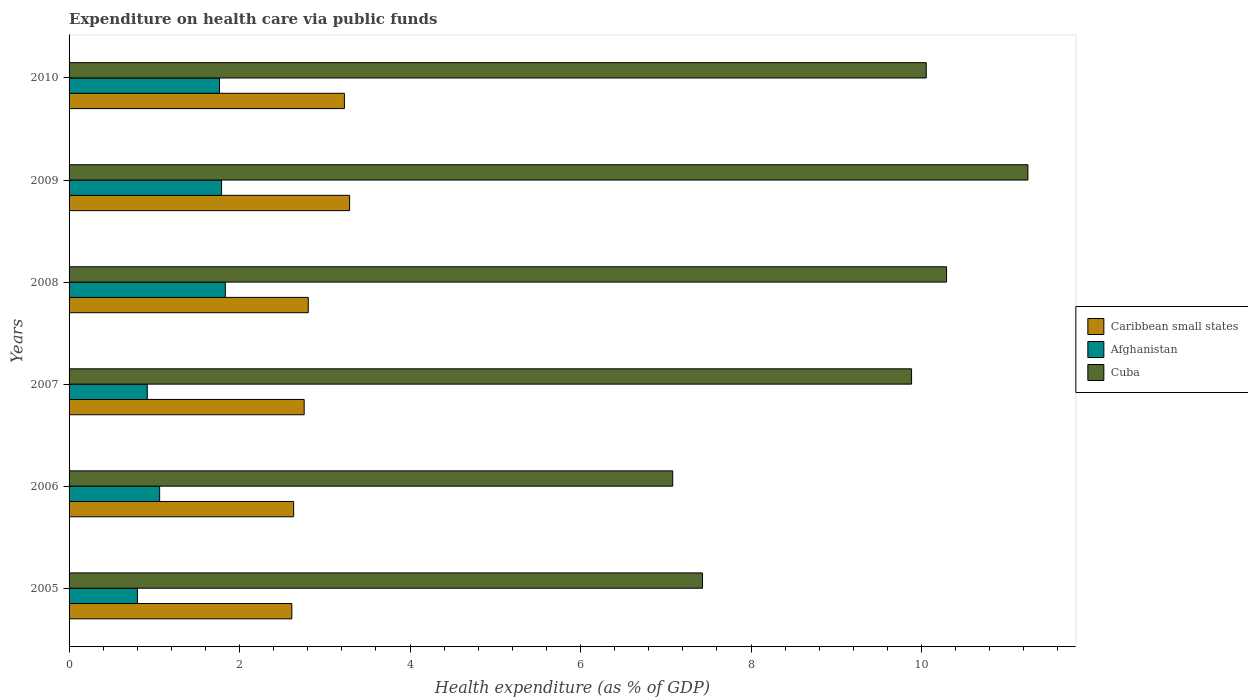Are the number of bars per tick equal to the number of legend labels?
Offer a terse response. Yes. How many bars are there on the 5th tick from the bottom?
Give a very brief answer. 3. What is the label of the 5th group of bars from the top?
Give a very brief answer. 2006. What is the expenditure made on health care in Afghanistan in 2010?
Offer a terse response. 1.76. Across all years, what is the maximum expenditure made on health care in Afghanistan?
Provide a short and direct response. 1.83. Across all years, what is the minimum expenditure made on health care in Cuba?
Provide a succinct answer. 7.08. In which year was the expenditure made on health care in Cuba maximum?
Your answer should be compact. 2009. In which year was the expenditure made on health care in Cuba minimum?
Your answer should be compact. 2006. What is the total expenditure made on health care in Caribbean small states in the graph?
Your response must be concise. 17.33. What is the difference between the expenditure made on health care in Cuba in 2005 and that in 2007?
Your answer should be very brief. -2.45. What is the difference between the expenditure made on health care in Caribbean small states in 2006 and the expenditure made on health care in Cuba in 2007?
Give a very brief answer. -7.25. What is the average expenditure made on health care in Afghanistan per year?
Your answer should be compact. 1.36. In the year 2006, what is the difference between the expenditure made on health care in Afghanistan and expenditure made on health care in Caribbean small states?
Provide a succinct answer. -1.57. In how many years, is the expenditure made on health care in Caribbean small states greater than 0.8 %?
Offer a very short reply. 6. What is the ratio of the expenditure made on health care in Cuba in 2005 to that in 2007?
Provide a succinct answer. 0.75. Is the difference between the expenditure made on health care in Afghanistan in 2007 and 2010 greater than the difference between the expenditure made on health care in Caribbean small states in 2007 and 2010?
Give a very brief answer. No. What is the difference between the highest and the second highest expenditure made on health care in Caribbean small states?
Ensure brevity in your answer.  0.06. What is the difference between the highest and the lowest expenditure made on health care in Afghanistan?
Offer a very short reply. 1.03. In how many years, is the expenditure made on health care in Caribbean small states greater than the average expenditure made on health care in Caribbean small states taken over all years?
Make the answer very short. 2. Is the sum of the expenditure made on health care in Cuba in 2007 and 2009 greater than the maximum expenditure made on health care in Afghanistan across all years?
Your response must be concise. Yes. What does the 3rd bar from the top in 2005 represents?
Your answer should be very brief. Caribbean small states. What does the 1st bar from the bottom in 2005 represents?
Keep it short and to the point. Caribbean small states. How many bars are there?
Your answer should be very brief. 18. How many years are there in the graph?
Provide a short and direct response. 6. Are the values on the major ticks of X-axis written in scientific E-notation?
Your answer should be compact. No. Does the graph contain any zero values?
Your response must be concise. No. Where does the legend appear in the graph?
Give a very brief answer. Center right. How are the legend labels stacked?
Your answer should be compact. Vertical. What is the title of the graph?
Make the answer very short. Expenditure on health care via public funds. What is the label or title of the X-axis?
Make the answer very short. Health expenditure (as % of GDP). What is the label or title of the Y-axis?
Your answer should be very brief. Years. What is the Health expenditure (as % of GDP) in Caribbean small states in 2005?
Make the answer very short. 2.61. What is the Health expenditure (as % of GDP) in Afghanistan in 2005?
Your response must be concise. 0.8. What is the Health expenditure (as % of GDP) in Cuba in 2005?
Make the answer very short. 7.43. What is the Health expenditure (as % of GDP) in Caribbean small states in 2006?
Your response must be concise. 2.63. What is the Health expenditure (as % of GDP) in Afghanistan in 2006?
Offer a very short reply. 1.06. What is the Health expenditure (as % of GDP) of Cuba in 2006?
Provide a short and direct response. 7.08. What is the Health expenditure (as % of GDP) in Caribbean small states in 2007?
Give a very brief answer. 2.76. What is the Health expenditure (as % of GDP) of Afghanistan in 2007?
Give a very brief answer. 0.92. What is the Health expenditure (as % of GDP) in Cuba in 2007?
Provide a succinct answer. 9.88. What is the Health expenditure (as % of GDP) in Caribbean small states in 2008?
Provide a succinct answer. 2.81. What is the Health expenditure (as % of GDP) in Afghanistan in 2008?
Your answer should be very brief. 1.83. What is the Health expenditure (as % of GDP) in Cuba in 2008?
Provide a succinct answer. 10.29. What is the Health expenditure (as % of GDP) in Caribbean small states in 2009?
Provide a succinct answer. 3.29. What is the Health expenditure (as % of GDP) of Afghanistan in 2009?
Provide a short and direct response. 1.79. What is the Health expenditure (as % of GDP) of Cuba in 2009?
Offer a very short reply. 11.25. What is the Health expenditure (as % of GDP) of Caribbean small states in 2010?
Your answer should be very brief. 3.23. What is the Health expenditure (as % of GDP) in Afghanistan in 2010?
Provide a succinct answer. 1.76. What is the Health expenditure (as % of GDP) in Cuba in 2010?
Give a very brief answer. 10.06. Across all years, what is the maximum Health expenditure (as % of GDP) of Caribbean small states?
Ensure brevity in your answer.  3.29. Across all years, what is the maximum Health expenditure (as % of GDP) in Afghanistan?
Offer a very short reply. 1.83. Across all years, what is the maximum Health expenditure (as % of GDP) in Cuba?
Keep it short and to the point. 11.25. Across all years, what is the minimum Health expenditure (as % of GDP) in Caribbean small states?
Make the answer very short. 2.61. Across all years, what is the minimum Health expenditure (as % of GDP) of Afghanistan?
Provide a succinct answer. 0.8. Across all years, what is the minimum Health expenditure (as % of GDP) of Cuba?
Your answer should be compact. 7.08. What is the total Health expenditure (as % of GDP) of Caribbean small states in the graph?
Your response must be concise. 17.33. What is the total Health expenditure (as % of GDP) of Afghanistan in the graph?
Offer a terse response. 8.17. What is the total Health expenditure (as % of GDP) of Cuba in the graph?
Your answer should be compact. 55.99. What is the difference between the Health expenditure (as % of GDP) in Caribbean small states in 2005 and that in 2006?
Your response must be concise. -0.02. What is the difference between the Health expenditure (as % of GDP) of Afghanistan in 2005 and that in 2006?
Keep it short and to the point. -0.26. What is the difference between the Health expenditure (as % of GDP) in Cuba in 2005 and that in 2006?
Provide a short and direct response. 0.35. What is the difference between the Health expenditure (as % of GDP) of Caribbean small states in 2005 and that in 2007?
Offer a terse response. -0.14. What is the difference between the Health expenditure (as % of GDP) of Afghanistan in 2005 and that in 2007?
Your answer should be compact. -0.12. What is the difference between the Health expenditure (as % of GDP) of Cuba in 2005 and that in 2007?
Provide a short and direct response. -2.45. What is the difference between the Health expenditure (as % of GDP) in Caribbean small states in 2005 and that in 2008?
Give a very brief answer. -0.19. What is the difference between the Health expenditure (as % of GDP) in Afghanistan in 2005 and that in 2008?
Provide a short and direct response. -1.03. What is the difference between the Health expenditure (as % of GDP) of Cuba in 2005 and that in 2008?
Keep it short and to the point. -2.86. What is the difference between the Health expenditure (as % of GDP) of Caribbean small states in 2005 and that in 2009?
Give a very brief answer. -0.68. What is the difference between the Health expenditure (as % of GDP) in Afghanistan in 2005 and that in 2009?
Your answer should be very brief. -0.99. What is the difference between the Health expenditure (as % of GDP) of Cuba in 2005 and that in 2009?
Your answer should be compact. -3.82. What is the difference between the Health expenditure (as % of GDP) of Caribbean small states in 2005 and that in 2010?
Keep it short and to the point. -0.62. What is the difference between the Health expenditure (as % of GDP) in Afghanistan in 2005 and that in 2010?
Provide a succinct answer. -0.96. What is the difference between the Health expenditure (as % of GDP) of Cuba in 2005 and that in 2010?
Your response must be concise. -2.62. What is the difference between the Health expenditure (as % of GDP) of Caribbean small states in 2006 and that in 2007?
Your response must be concise. -0.12. What is the difference between the Health expenditure (as % of GDP) in Afghanistan in 2006 and that in 2007?
Make the answer very short. 0.14. What is the difference between the Health expenditure (as % of GDP) of Cuba in 2006 and that in 2007?
Your response must be concise. -2.8. What is the difference between the Health expenditure (as % of GDP) of Caribbean small states in 2006 and that in 2008?
Your answer should be very brief. -0.17. What is the difference between the Health expenditure (as % of GDP) of Afghanistan in 2006 and that in 2008?
Make the answer very short. -0.77. What is the difference between the Health expenditure (as % of GDP) of Cuba in 2006 and that in 2008?
Keep it short and to the point. -3.21. What is the difference between the Health expenditure (as % of GDP) of Caribbean small states in 2006 and that in 2009?
Your answer should be very brief. -0.66. What is the difference between the Health expenditure (as % of GDP) of Afghanistan in 2006 and that in 2009?
Your answer should be compact. -0.73. What is the difference between the Health expenditure (as % of GDP) in Cuba in 2006 and that in 2009?
Offer a terse response. -4.17. What is the difference between the Health expenditure (as % of GDP) in Caribbean small states in 2006 and that in 2010?
Your answer should be compact. -0.6. What is the difference between the Health expenditure (as % of GDP) of Afghanistan in 2006 and that in 2010?
Give a very brief answer. -0.7. What is the difference between the Health expenditure (as % of GDP) of Cuba in 2006 and that in 2010?
Make the answer very short. -2.97. What is the difference between the Health expenditure (as % of GDP) of Caribbean small states in 2007 and that in 2008?
Make the answer very short. -0.05. What is the difference between the Health expenditure (as % of GDP) in Afghanistan in 2007 and that in 2008?
Provide a succinct answer. -0.92. What is the difference between the Health expenditure (as % of GDP) of Cuba in 2007 and that in 2008?
Provide a succinct answer. -0.41. What is the difference between the Health expenditure (as % of GDP) in Caribbean small states in 2007 and that in 2009?
Make the answer very short. -0.53. What is the difference between the Health expenditure (as % of GDP) of Afghanistan in 2007 and that in 2009?
Make the answer very short. -0.87. What is the difference between the Health expenditure (as % of GDP) of Cuba in 2007 and that in 2009?
Your response must be concise. -1.36. What is the difference between the Health expenditure (as % of GDP) in Caribbean small states in 2007 and that in 2010?
Keep it short and to the point. -0.47. What is the difference between the Health expenditure (as % of GDP) of Afghanistan in 2007 and that in 2010?
Offer a very short reply. -0.85. What is the difference between the Health expenditure (as % of GDP) of Cuba in 2007 and that in 2010?
Ensure brevity in your answer.  -0.17. What is the difference between the Health expenditure (as % of GDP) in Caribbean small states in 2008 and that in 2009?
Give a very brief answer. -0.48. What is the difference between the Health expenditure (as % of GDP) of Afghanistan in 2008 and that in 2009?
Make the answer very short. 0.04. What is the difference between the Health expenditure (as % of GDP) in Cuba in 2008 and that in 2009?
Provide a succinct answer. -0.95. What is the difference between the Health expenditure (as % of GDP) in Caribbean small states in 2008 and that in 2010?
Provide a succinct answer. -0.42. What is the difference between the Health expenditure (as % of GDP) in Afghanistan in 2008 and that in 2010?
Provide a succinct answer. 0.07. What is the difference between the Health expenditure (as % of GDP) of Cuba in 2008 and that in 2010?
Ensure brevity in your answer.  0.24. What is the difference between the Health expenditure (as % of GDP) in Caribbean small states in 2009 and that in 2010?
Offer a very short reply. 0.06. What is the difference between the Health expenditure (as % of GDP) in Afghanistan in 2009 and that in 2010?
Your answer should be very brief. 0.02. What is the difference between the Health expenditure (as % of GDP) of Cuba in 2009 and that in 2010?
Make the answer very short. 1.19. What is the difference between the Health expenditure (as % of GDP) in Caribbean small states in 2005 and the Health expenditure (as % of GDP) in Afghanistan in 2006?
Provide a succinct answer. 1.55. What is the difference between the Health expenditure (as % of GDP) in Caribbean small states in 2005 and the Health expenditure (as % of GDP) in Cuba in 2006?
Your response must be concise. -4.47. What is the difference between the Health expenditure (as % of GDP) of Afghanistan in 2005 and the Health expenditure (as % of GDP) of Cuba in 2006?
Give a very brief answer. -6.28. What is the difference between the Health expenditure (as % of GDP) of Caribbean small states in 2005 and the Health expenditure (as % of GDP) of Afghanistan in 2007?
Offer a terse response. 1.7. What is the difference between the Health expenditure (as % of GDP) in Caribbean small states in 2005 and the Health expenditure (as % of GDP) in Cuba in 2007?
Provide a succinct answer. -7.27. What is the difference between the Health expenditure (as % of GDP) of Afghanistan in 2005 and the Health expenditure (as % of GDP) of Cuba in 2007?
Make the answer very short. -9.08. What is the difference between the Health expenditure (as % of GDP) in Caribbean small states in 2005 and the Health expenditure (as % of GDP) in Afghanistan in 2008?
Your response must be concise. 0.78. What is the difference between the Health expenditure (as % of GDP) of Caribbean small states in 2005 and the Health expenditure (as % of GDP) of Cuba in 2008?
Your response must be concise. -7.68. What is the difference between the Health expenditure (as % of GDP) of Afghanistan in 2005 and the Health expenditure (as % of GDP) of Cuba in 2008?
Give a very brief answer. -9.49. What is the difference between the Health expenditure (as % of GDP) in Caribbean small states in 2005 and the Health expenditure (as % of GDP) in Afghanistan in 2009?
Your response must be concise. 0.82. What is the difference between the Health expenditure (as % of GDP) in Caribbean small states in 2005 and the Health expenditure (as % of GDP) in Cuba in 2009?
Your answer should be compact. -8.63. What is the difference between the Health expenditure (as % of GDP) in Afghanistan in 2005 and the Health expenditure (as % of GDP) in Cuba in 2009?
Ensure brevity in your answer.  -10.45. What is the difference between the Health expenditure (as % of GDP) in Caribbean small states in 2005 and the Health expenditure (as % of GDP) in Afghanistan in 2010?
Keep it short and to the point. 0.85. What is the difference between the Health expenditure (as % of GDP) of Caribbean small states in 2005 and the Health expenditure (as % of GDP) of Cuba in 2010?
Make the answer very short. -7.44. What is the difference between the Health expenditure (as % of GDP) in Afghanistan in 2005 and the Health expenditure (as % of GDP) in Cuba in 2010?
Provide a succinct answer. -9.25. What is the difference between the Health expenditure (as % of GDP) in Caribbean small states in 2006 and the Health expenditure (as % of GDP) in Afghanistan in 2007?
Give a very brief answer. 1.72. What is the difference between the Health expenditure (as % of GDP) of Caribbean small states in 2006 and the Health expenditure (as % of GDP) of Cuba in 2007?
Provide a succinct answer. -7.25. What is the difference between the Health expenditure (as % of GDP) in Afghanistan in 2006 and the Health expenditure (as % of GDP) in Cuba in 2007?
Your answer should be compact. -8.82. What is the difference between the Health expenditure (as % of GDP) of Caribbean small states in 2006 and the Health expenditure (as % of GDP) of Afghanistan in 2008?
Give a very brief answer. 0.8. What is the difference between the Health expenditure (as % of GDP) in Caribbean small states in 2006 and the Health expenditure (as % of GDP) in Cuba in 2008?
Make the answer very short. -7.66. What is the difference between the Health expenditure (as % of GDP) of Afghanistan in 2006 and the Health expenditure (as % of GDP) of Cuba in 2008?
Your response must be concise. -9.23. What is the difference between the Health expenditure (as % of GDP) of Caribbean small states in 2006 and the Health expenditure (as % of GDP) of Afghanistan in 2009?
Offer a very short reply. 0.85. What is the difference between the Health expenditure (as % of GDP) of Caribbean small states in 2006 and the Health expenditure (as % of GDP) of Cuba in 2009?
Keep it short and to the point. -8.61. What is the difference between the Health expenditure (as % of GDP) in Afghanistan in 2006 and the Health expenditure (as % of GDP) in Cuba in 2009?
Your answer should be compact. -10.19. What is the difference between the Health expenditure (as % of GDP) in Caribbean small states in 2006 and the Health expenditure (as % of GDP) in Afghanistan in 2010?
Your answer should be very brief. 0.87. What is the difference between the Health expenditure (as % of GDP) of Caribbean small states in 2006 and the Health expenditure (as % of GDP) of Cuba in 2010?
Keep it short and to the point. -7.42. What is the difference between the Health expenditure (as % of GDP) of Afghanistan in 2006 and the Health expenditure (as % of GDP) of Cuba in 2010?
Ensure brevity in your answer.  -8.99. What is the difference between the Health expenditure (as % of GDP) of Caribbean small states in 2007 and the Health expenditure (as % of GDP) of Afghanistan in 2008?
Your answer should be compact. 0.93. What is the difference between the Health expenditure (as % of GDP) of Caribbean small states in 2007 and the Health expenditure (as % of GDP) of Cuba in 2008?
Provide a short and direct response. -7.54. What is the difference between the Health expenditure (as % of GDP) in Afghanistan in 2007 and the Health expenditure (as % of GDP) in Cuba in 2008?
Your response must be concise. -9.38. What is the difference between the Health expenditure (as % of GDP) of Caribbean small states in 2007 and the Health expenditure (as % of GDP) of Afghanistan in 2009?
Keep it short and to the point. 0.97. What is the difference between the Health expenditure (as % of GDP) in Caribbean small states in 2007 and the Health expenditure (as % of GDP) in Cuba in 2009?
Offer a terse response. -8.49. What is the difference between the Health expenditure (as % of GDP) of Afghanistan in 2007 and the Health expenditure (as % of GDP) of Cuba in 2009?
Provide a succinct answer. -10.33. What is the difference between the Health expenditure (as % of GDP) in Caribbean small states in 2007 and the Health expenditure (as % of GDP) in Afghanistan in 2010?
Make the answer very short. 0.99. What is the difference between the Health expenditure (as % of GDP) in Caribbean small states in 2007 and the Health expenditure (as % of GDP) in Cuba in 2010?
Give a very brief answer. -7.3. What is the difference between the Health expenditure (as % of GDP) of Afghanistan in 2007 and the Health expenditure (as % of GDP) of Cuba in 2010?
Your response must be concise. -9.14. What is the difference between the Health expenditure (as % of GDP) in Caribbean small states in 2008 and the Health expenditure (as % of GDP) in Afghanistan in 2009?
Keep it short and to the point. 1.02. What is the difference between the Health expenditure (as % of GDP) in Caribbean small states in 2008 and the Health expenditure (as % of GDP) in Cuba in 2009?
Your response must be concise. -8.44. What is the difference between the Health expenditure (as % of GDP) of Afghanistan in 2008 and the Health expenditure (as % of GDP) of Cuba in 2009?
Give a very brief answer. -9.41. What is the difference between the Health expenditure (as % of GDP) of Caribbean small states in 2008 and the Health expenditure (as % of GDP) of Afghanistan in 2010?
Offer a very short reply. 1.04. What is the difference between the Health expenditure (as % of GDP) of Caribbean small states in 2008 and the Health expenditure (as % of GDP) of Cuba in 2010?
Make the answer very short. -7.25. What is the difference between the Health expenditure (as % of GDP) of Afghanistan in 2008 and the Health expenditure (as % of GDP) of Cuba in 2010?
Offer a very short reply. -8.22. What is the difference between the Health expenditure (as % of GDP) of Caribbean small states in 2009 and the Health expenditure (as % of GDP) of Afghanistan in 2010?
Make the answer very short. 1.53. What is the difference between the Health expenditure (as % of GDP) in Caribbean small states in 2009 and the Health expenditure (as % of GDP) in Cuba in 2010?
Keep it short and to the point. -6.76. What is the difference between the Health expenditure (as % of GDP) in Afghanistan in 2009 and the Health expenditure (as % of GDP) in Cuba in 2010?
Make the answer very short. -8.27. What is the average Health expenditure (as % of GDP) in Caribbean small states per year?
Your answer should be very brief. 2.89. What is the average Health expenditure (as % of GDP) in Afghanistan per year?
Your response must be concise. 1.36. What is the average Health expenditure (as % of GDP) in Cuba per year?
Ensure brevity in your answer.  9.33. In the year 2005, what is the difference between the Health expenditure (as % of GDP) of Caribbean small states and Health expenditure (as % of GDP) of Afghanistan?
Keep it short and to the point. 1.81. In the year 2005, what is the difference between the Health expenditure (as % of GDP) in Caribbean small states and Health expenditure (as % of GDP) in Cuba?
Give a very brief answer. -4.82. In the year 2005, what is the difference between the Health expenditure (as % of GDP) of Afghanistan and Health expenditure (as % of GDP) of Cuba?
Your answer should be very brief. -6.63. In the year 2006, what is the difference between the Health expenditure (as % of GDP) of Caribbean small states and Health expenditure (as % of GDP) of Afghanistan?
Your answer should be very brief. 1.57. In the year 2006, what is the difference between the Health expenditure (as % of GDP) in Caribbean small states and Health expenditure (as % of GDP) in Cuba?
Your response must be concise. -4.45. In the year 2006, what is the difference between the Health expenditure (as % of GDP) of Afghanistan and Health expenditure (as % of GDP) of Cuba?
Offer a terse response. -6.02. In the year 2007, what is the difference between the Health expenditure (as % of GDP) of Caribbean small states and Health expenditure (as % of GDP) of Afghanistan?
Ensure brevity in your answer.  1.84. In the year 2007, what is the difference between the Health expenditure (as % of GDP) of Caribbean small states and Health expenditure (as % of GDP) of Cuba?
Give a very brief answer. -7.13. In the year 2007, what is the difference between the Health expenditure (as % of GDP) of Afghanistan and Health expenditure (as % of GDP) of Cuba?
Offer a very short reply. -8.97. In the year 2008, what is the difference between the Health expenditure (as % of GDP) of Caribbean small states and Health expenditure (as % of GDP) of Afghanistan?
Offer a very short reply. 0.97. In the year 2008, what is the difference between the Health expenditure (as % of GDP) in Caribbean small states and Health expenditure (as % of GDP) in Cuba?
Keep it short and to the point. -7.49. In the year 2008, what is the difference between the Health expenditure (as % of GDP) in Afghanistan and Health expenditure (as % of GDP) in Cuba?
Give a very brief answer. -8.46. In the year 2009, what is the difference between the Health expenditure (as % of GDP) of Caribbean small states and Health expenditure (as % of GDP) of Afghanistan?
Give a very brief answer. 1.5. In the year 2009, what is the difference between the Health expenditure (as % of GDP) of Caribbean small states and Health expenditure (as % of GDP) of Cuba?
Give a very brief answer. -7.96. In the year 2009, what is the difference between the Health expenditure (as % of GDP) in Afghanistan and Health expenditure (as % of GDP) in Cuba?
Your response must be concise. -9.46. In the year 2010, what is the difference between the Health expenditure (as % of GDP) of Caribbean small states and Health expenditure (as % of GDP) of Afghanistan?
Provide a succinct answer. 1.47. In the year 2010, what is the difference between the Health expenditure (as % of GDP) in Caribbean small states and Health expenditure (as % of GDP) in Cuba?
Keep it short and to the point. -6.83. In the year 2010, what is the difference between the Health expenditure (as % of GDP) of Afghanistan and Health expenditure (as % of GDP) of Cuba?
Your response must be concise. -8.29. What is the ratio of the Health expenditure (as % of GDP) in Afghanistan in 2005 to that in 2006?
Give a very brief answer. 0.75. What is the ratio of the Health expenditure (as % of GDP) of Cuba in 2005 to that in 2006?
Offer a terse response. 1.05. What is the ratio of the Health expenditure (as % of GDP) in Caribbean small states in 2005 to that in 2007?
Offer a terse response. 0.95. What is the ratio of the Health expenditure (as % of GDP) in Afghanistan in 2005 to that in 2007?
Your answer should be very brief. 0.87. What is the ratio of the Health expenditure (as % of GDP) in Cuba in 2005 to that in 2007?
Your answer should be very brief. 0.75. What is the ratio of the Health expenditure (as % of GDP) in Caribbean small states in 2005 to that in 2008?
Ensure brevity in your answer.  0.93. What is the ratio of the Health expenditure (as % of GDP) of Afghanistan in 2005 to that in 2008?
Your response must be concise. 0.44. What is the ratio of the Health expenditure (as % of GDP) in Cuba in 2005 to that in 2008?
Keep it short and to the point. 0.72. What is the ratio of the Health expenditure (as % of GDP) in Caribbean small states in 2005 to that in 2009?
Ensure brevity in your answer.  0.79. What is the ratio of the Health expenditure (as % of GDP) in Afghanistan in 2005 to that in 2009?
Offer a terse response. 0.45. What is the ratio of the Health expenditure (as % of GDP) of Cuba in 2005 to that in 2009?
Keep it short and to the point. 0.66. What is the ratio of the Health expenditure (as % of GDP) of Caribbean small states in 2005 to that in 2010?
Keep it short and to the point. 0.81. What is the ratio of the Health expenditure (as % of GDP) in Afghanistan in 2005 to that in 2010?
Your answer should be compact. 0.45. What is the ratio of the Health expenditure (as % of GDP) of Cuba in 2005 to that in 2010?
Your response must be concise. 0.74. What is the ratio of the Health expenditure (as % of GDP) of Caribbean small states in 2006 to that in 2007?
Your answer should be compact. 0.96. What is the ratio of the Health expenditure (as % of GDP) of Afghanistan in 2006 to that in 2007?
Give a very brief answer. 1.16. What is the ratio of the Health expenditure (as % of GDP) of Cuba in 2006 to that in 2007?
Offer a very short reply. 0.72. What is the ratio of the Health expenditure (as % of GDP) in Caribbean small states in 2006 to that in 2008?
Give a very brief answer. 0.94. What is the ratio of the Health expenditure (as % of GDP) in Afghanistan in 2006 to that in 2008?
Ensure brevity in your answer.  0.58. What is the ratio of the Health expenditure (as % of GDP) of Cuba in 2006 to that in 2008?
Keep it short and to the point. 0.69. What is the ratio of the Health expenditure (as % of GDP) in Caribbean small states in 2006 to that in 2009?
Make the answer very short. 0.8. What is the ratio of the Health expenditure (as % of GDP) of Afghanistan in 2006 to that in 2009?
Give a very brief answer. 0.59. What is the ratio of the Health expenditure (as % of GDP) in Cuba in 2006 to that in 2009?
Ensure brevity in your answer.  0.63. What is the ratio of the Health expenditure (as % of GDP) in Caribbean small states in 2006 to that in 2010?
Provide a succinct answer. 0.82. What is the ratio of the Health expenditure (as % of GDP) of Afghanistan in 2006 to that in 2010?
Offer a terse response. 0.6. What is the ratio of the Health expenditure (as % of GDP) in Cuba in 2006 to that in 2010?
Offer a terse response. 0.7. What is the ratio of the Health expenditure (as % of GDP) of Caribbean small states in 2007 to that in 2008?
Your answer should be very brief. 0.98. What is the ratio of the Health expenditure (as % of GDP) in Afghanistan in 2007 to that in 2008?
Provide a short and direct response. 0.5. What is the ratio of the Health expenditure (as % of GDP) of Cuba in 2007 to that in 2008?
Keep it short and to the point. 0.96. What is the ratio of the Health expenditure (as % of GDP) in Caribbean small states in 2007 to that in 2009?
Provide a short and direct response. 0.84. What is the ratio of the Health expenditure (as % of GDP) of Afghanistan in 2007 to that in 2009?
Offer a terse response. 0.51. What is the ratio of the Health expenditure (as % of GDP) in Cuba in 2007 to that in 2009?
Provide a short and direct response. 0.88. What is the ratio of the Health expenditure (as % of GDP) in Caribbean small states in 2007 to that in 2010?
Your answer should be compact. 0.85. What is the ratio of the Health expenditure (as % of GDP) in Afghanistan in 2007 to that in 2010?
Offer a very short reply. 0.52. What is the ratio of the Health expenditure (as % of GDP) of Cuba in 2007 to that in 2010?
Give a very brief answer. 0.98. What is the ratio of the Health expenditure (as % of GDP) of Caribbean small states in 2008 to that in 2009?
Ensure brevity in your answer.  0.85. What is the ratio of the Health expenditure (as % of GDP) in Afghanistan in 2008 to that in 2009?
Offer a very short reply. 1.02. What is the ratio of the Health expenditure (as % of GDP) of Cuba in 2008 to that in 2009?
Keep it short and to the point. 0.92. What is the ratio of the Health expenditure (as % of GDP) of Caribbean small states in 2008 to that in 2010?
Offer a terse response. 0.87. What is the ratio of the Health expenditure (as % of GDP) in Afghanistan in 2008 to that in 2010?
Make the answer very short. 1.04. What is the ratio of the Health expenditure (as % of GDP) in Cuba in 2008 to that in 2010?
Your answer should be very brief. 1.02. What is the ratio of the Health expenditure (as % of GDP) of Caribbean small states in 2009 to that in 2010?
Your response must be concise. 1.02. What is the ratio of the Health expenditure (as % of GDP) of Afghanistan in 2009 to that in 2010?
Ensure brevity in your answer.  1.01. What is the ratio of the Health expenditure (as % of GDP) in Cuba in 2009 to that in 2010?
Offer a terse response. 1.12. What is the difference between the highest and the second highest Health expenditure (as % of GDP) of Caribbean small states?
Give a very brief answer. 0.06. What is the difference between the highest and the second highest Health expenditure (as % of GDP) in Afghanistan?
Make the answer very short. 0.04. What is the difference between the highest and the second highest Health expenditure (as % of GDP) in Cuba?
Ensure brevity in your answer.  0.95. What is the difference between the highest and the lowest Health expenditure (as % of GDP) in Caribbean small states?
Ensure brevity in your answer.  0.68. What is the difference between the highest and the lowest Health expenditure (as % of GDP) in Afghanistan?
Provide a succinct answer. 1.03. What is the difference between the highest and the lowest Health expenditure (as % of GDP) of Cuba?
Give a very brief answer. 4.17. 